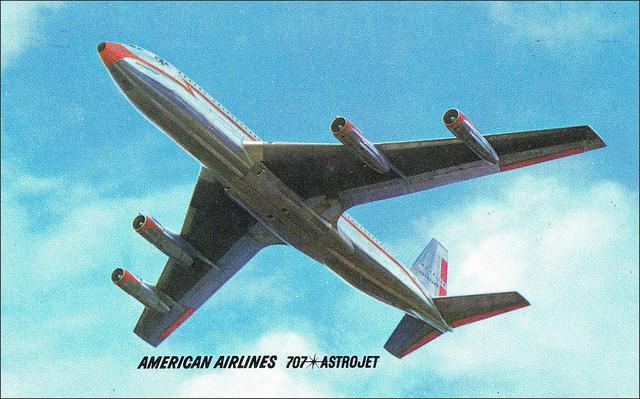Sunny or overcast?
Concise answer only. Sunny. Is this a drawling or a photograph?
Give a very brief answer. Drawing. How big is this plane?
Concise answer only. Huge. 